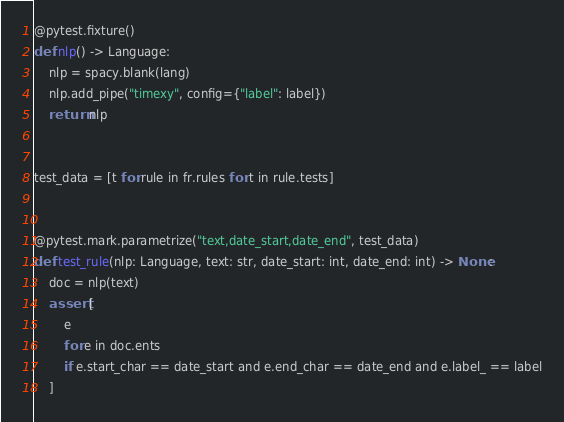<code> <loc_0><loc_0><loc_500><loc_500><_Python_>
@pytest.fixture()
def nlp() -> Language:
    nlp = spacy.blank(lang)
    nlp.add_pipe("timexy", config={"label": label})
    return nlp


test_data = [t for rule in fr.rules for t in rule.tests]


@pytest.mark.parametrize("text,date_start,date_end", test_data)
def test_rule(nlp: Language, text: str, date_start: int, date_end: int) -> None:
    doc = nlp(text)
    assert [
        e
        for e in doc.ents
        if e.start_char == date_start and e.end_char == date_end and e.label_ == label
    ]
</code> 